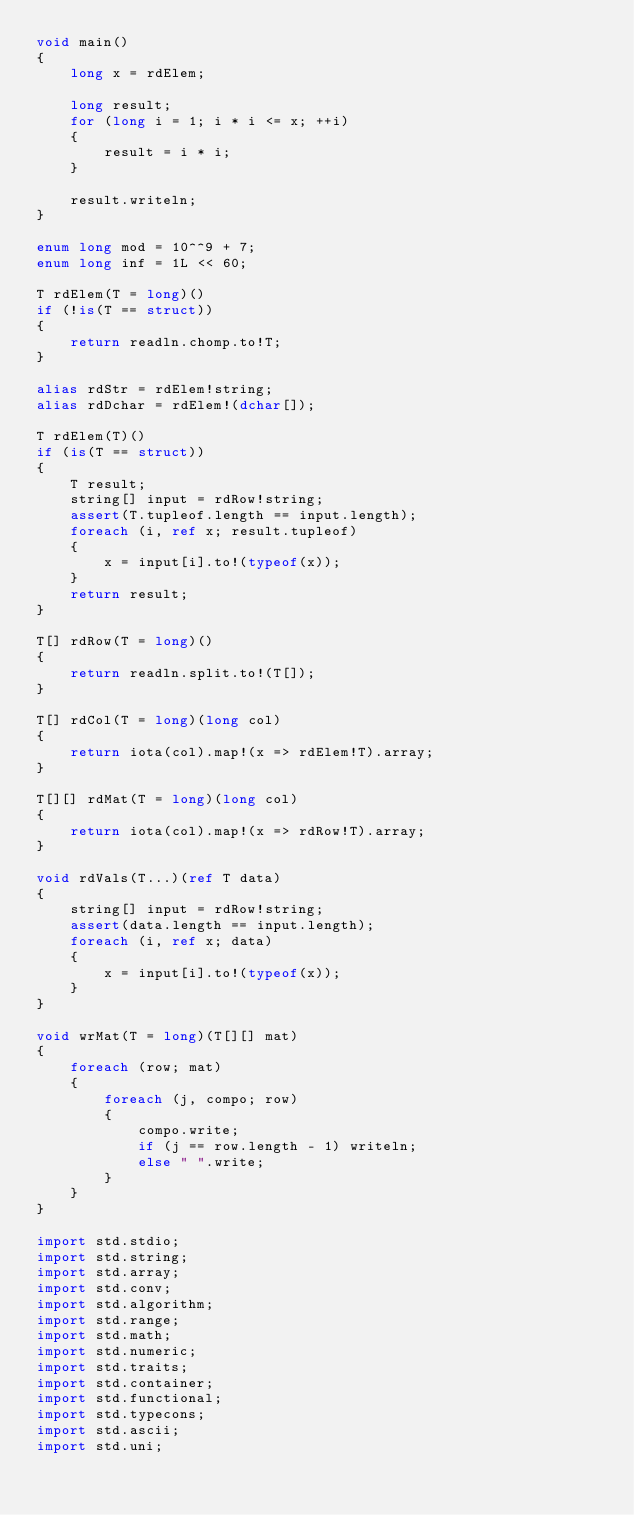Convert code to text. <code><loc_0><loc_0><loc_500><loc_500><_D_>void main()
{
    long x = rdElem;

    long result;
    for (long i = 1; i * i <= x; ++i)
    {
        result = i * i;
    }

    result.writeln;
}

enum long mod = 10^^9 + 7;
enum long inf = 1L << 60;

T rdElem(T = long)()
if (!is(T == struct))
{
    return readln.chomp.to!T;
}

alias rdStr = rdElem!string;
alias rdDchar = rdElem!(dchar[]);

T rdElem(T)()
if (is(T == struct))
{
    T result;
    string[] input = rdRow!string;
    assert(T.tupleof.length == input.length);
    foreach (i, ref x; result.tupleof)
    {
        x = input[i].to!(typeof(x));
    }
    return result;
}

T[] rdRow(T = long)()
{
    return readln.split.to!(T[]);
}

T[] rdCol(T = long)(long col)
{
    return iota(col).map!(x => rdElem!T).array;
}

T[][] rdMat(T = long)(long col)
{
    return iota(col).map!(x => rdRow!T).array;
}

void rdVals(T...)(ref T data)
{
    string[] input = rdRow!string;
    assert(data.length == input.length);
    foreach (i, ref x; data)
    {
        x = input[i].to!(typeof(x));
    }
}

void wrMat(T = long)(T[][] mat)
{
    foreach (row; mat)
    {
        foreach (j, compo; row)
        {
            compo.write;
            if (j == row.length - 1) writeln;
            else " ".write;
        }
    }
}

import std.stdio;
import std.string;
import std.array;
import std.conv;
import std.algorithm;
import std.range;
import std.math;
import std.numeric;
import std.traits;
import std.container;
import std.functional;
import std.typecons;
import std.ascii;
import std.uni;</code> 